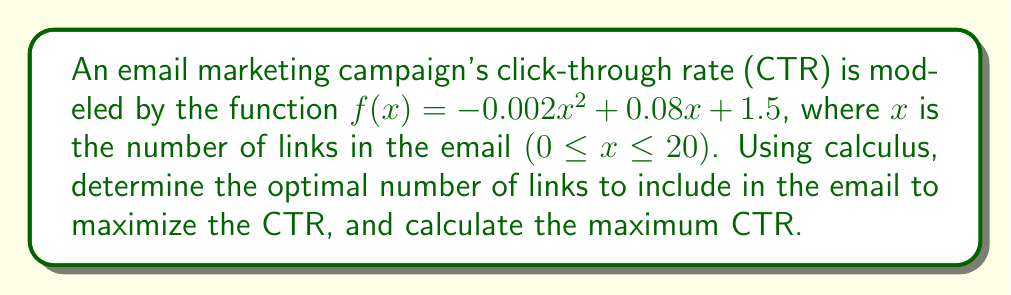Show me your answer to this math problem. To find the optimal number of links that maximizes the CTR, we need to follow these steps:

1. Find the derivative of the function:
   $$f'(x) = -0.004x + 0.08$$

2. Set the derivative equal to zero to find the critical point:
   $$-0.004x + 0.08 = 0$$
   $$-0.004x = -0.08$$
   $$x = 20$$

3. Verify that this critical point is a maximum by checking the second derivative:
   $$f''(x) = -0.004$$
   Since $f''(x)$ is negative, the critical point is a maximum.

4. Calculate the maximum CTR by plugging the optimal number of links into the original function:
   $$f(20) = -0.002(20)^2 + 0.08(20) + 1.5$$
   $$= -0.8 + 1.6 + 1.5$$
   $$= 2.3$$

Therefore, the optimal number of links is 20, and the maximum CTR is 2.3%.
Answer: 20 links; 2.3% CTR 